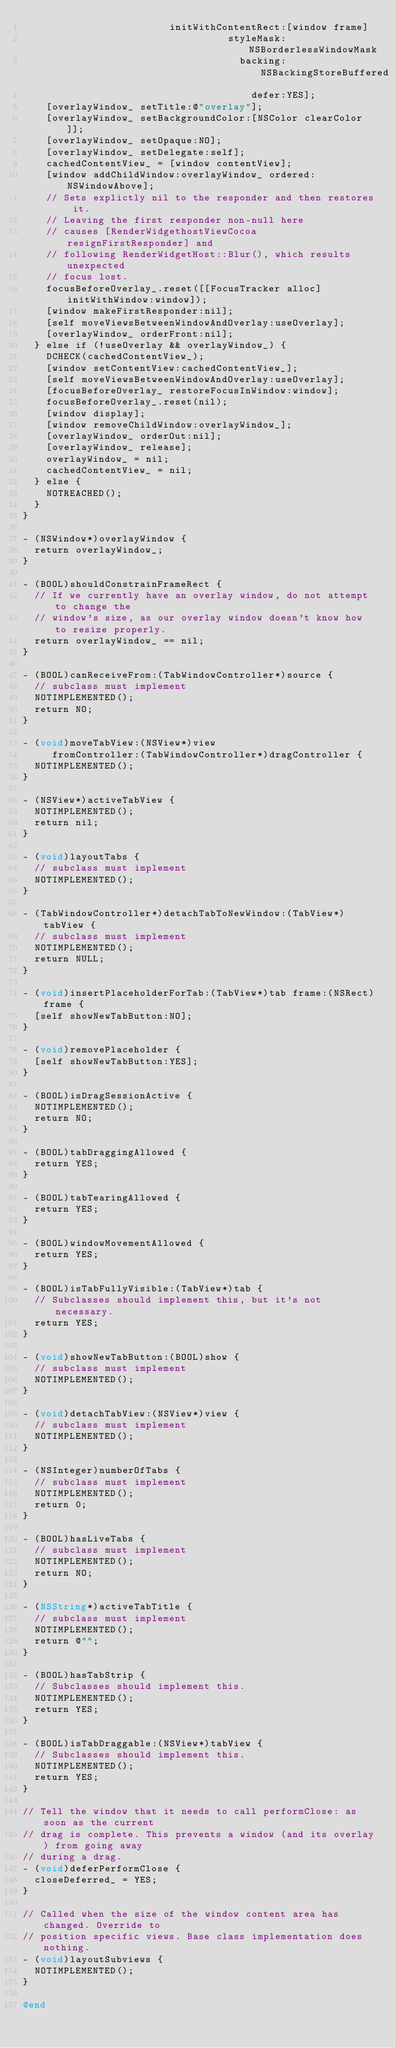<code> <loc_0><loc_0><loc_500><loc_500><_ObjectiveC_>                         initWithContentRect:[window frame]
                                   styleMask:NSBorderlessWindowMask
                                     backing:NSBackingStoreBuffered
                                       defer:YES];
    [overlayWindow_ setTitle:@"overlay"];
    [overlayWindow_ setBackgroundColor:[NSColor clearColor]];
    [overlayWindow_ setOpaque:NO];
    [overlayWindow_ setDelegate:self];
    cachedContentView_ = [window contentView];
    [window addChildWindow:overlayWindow_ ordered:NSWindowAbove];
    // Sets explictly nil to the responder and then restores it.
    // Leaving the first responder non-null here
    // causes [RenderWidgethostViewCocoa resignFirstResponder] and
    // following RenderWidgetHost::Blur(), which results unexpected
    // focus lost.
    focusBeforeOverlay_.reset([[FocusTracker alloc] initWithWindow:window]);
    [window makeFirstResponder:nil];
    [self moveViewsBetweenWindowAndOverlay:useOverlay];
    [overlayWindow_ orderFront:nil];
  } else if (!useOverlay && overlayWindow_) {
    DCHECK(cachedContentView_);
    [window setContentView:cachedContentView_];
    [self moveViewsBetweenWindowAndOverlay:useOverlay];
    [focusBeforeOverlay_ restoreFocusInWindow:window];
    focusBeforeOverlay_.reset(nil);
    [window display];
    [window removeChildWindow:overlayWindow_];
    [overlayWindow_ orderOut:nil];
    [overlayWindow_ release];
    overlayWindow_ = nil;
    cachedContentView_ = nil;
  } else {
    NOTREACHED();
  }
}

- (NSWindow*)overlayWindow {
  return overlayWindow_;
}

- (BOOL)shouldConstrainFrameRect {
  // If we currently have an overlay window, do not attempt to change the
  // window's size, as our overlay window doesn't know how to resize properly.
  return overlayWindow_ == nil;
}

- (BOOL)canReceiveFrom:(TabWindowController*)source {
  // subclass must implement
  NOTIMPLEMENTED();
  return NO;
}

- (void)moveTabView:(NSView*)view
     fromController:(TabWindowController*)dragController {
  NOTIMPLEMENTED();
}

- (NSView*)activeTabView {
  NOTIMPLEMENTED();
  return nil;
}

- (void)layoutTabs {
  // subclass must implement
  NOTIMPLEMENTED();
}

- (TabWindowController*)detachTabToNewWindow:(TabView*)tabView {
  // subclass must implement
  NOTIMPLEMENTED();
  return NULL;
}

- (void)insertPlaceholderForTab:(TabView*)tab frame:(NSRect)frame {
  [self showNewTabButton:NO];
}

- (void)removePlaceholder {
  [self showNewTabButton:YES];
}

- (BOOL)isDragSessionActive {
  NOTIMPLEMENTED();
  return NO;
}

- (BOOL)tabDraggingAllowed {
  return YES;
}

- (BOOL)tabTearingAllowed {
  return YES;
}

- (BOOL)windowMovementAllowed {
  return YES;
}

- (BOOL)isTabFullyVisible:(TabView*)tab {
  // Subclasses should implement this, but it's not necessary.
  return YES;
}

- (void)showNewTabButton:(BOOL)show {
  // subclass must implement
  NOTIMPLEMENTED();
}

- (void)detachTabView:(NSView*)view {
  // subclass must implement
  NOTIMPLEMENTED();
}

- (NSInteger)numberOfTabs {
  // subclass must implement
  NOTIMPLEMENTED();
  return 0;
}

- (BOOL)hasLiveTabs {
  // subclass must implement
  NOTIMPLEMENTED();
  return NO;
}

- (NSString*)activeTabTitle {
  // subclass must implement
  NOTIMPLEMENTED();
  return @"";
}

- (BOOL)hasTabStrip {
  // Subclasses should implement this.
  NOTIMPLEMENTED();
  return YES;
}

- (BOOL)isTabDraggable:(NSView*)tabView {
  // Subclasses should implement this.
  NOTIMPLEMENTED();
  return YES;
}

// Tell the window that it needs to call performClose: as soon as the current
// drag is complete. This prevents a window (and its overlay) from going away
// during a drag.
- (void)deferPerformClose {
  closeDeferred_ = YES;
}

// Called when the size of the window content area has changed. Override to
// position specific views. Base class implementation does nothing.
- (void)layoutSubviews {
  NOTIMPLEMENTED();
}

@end
</code> 